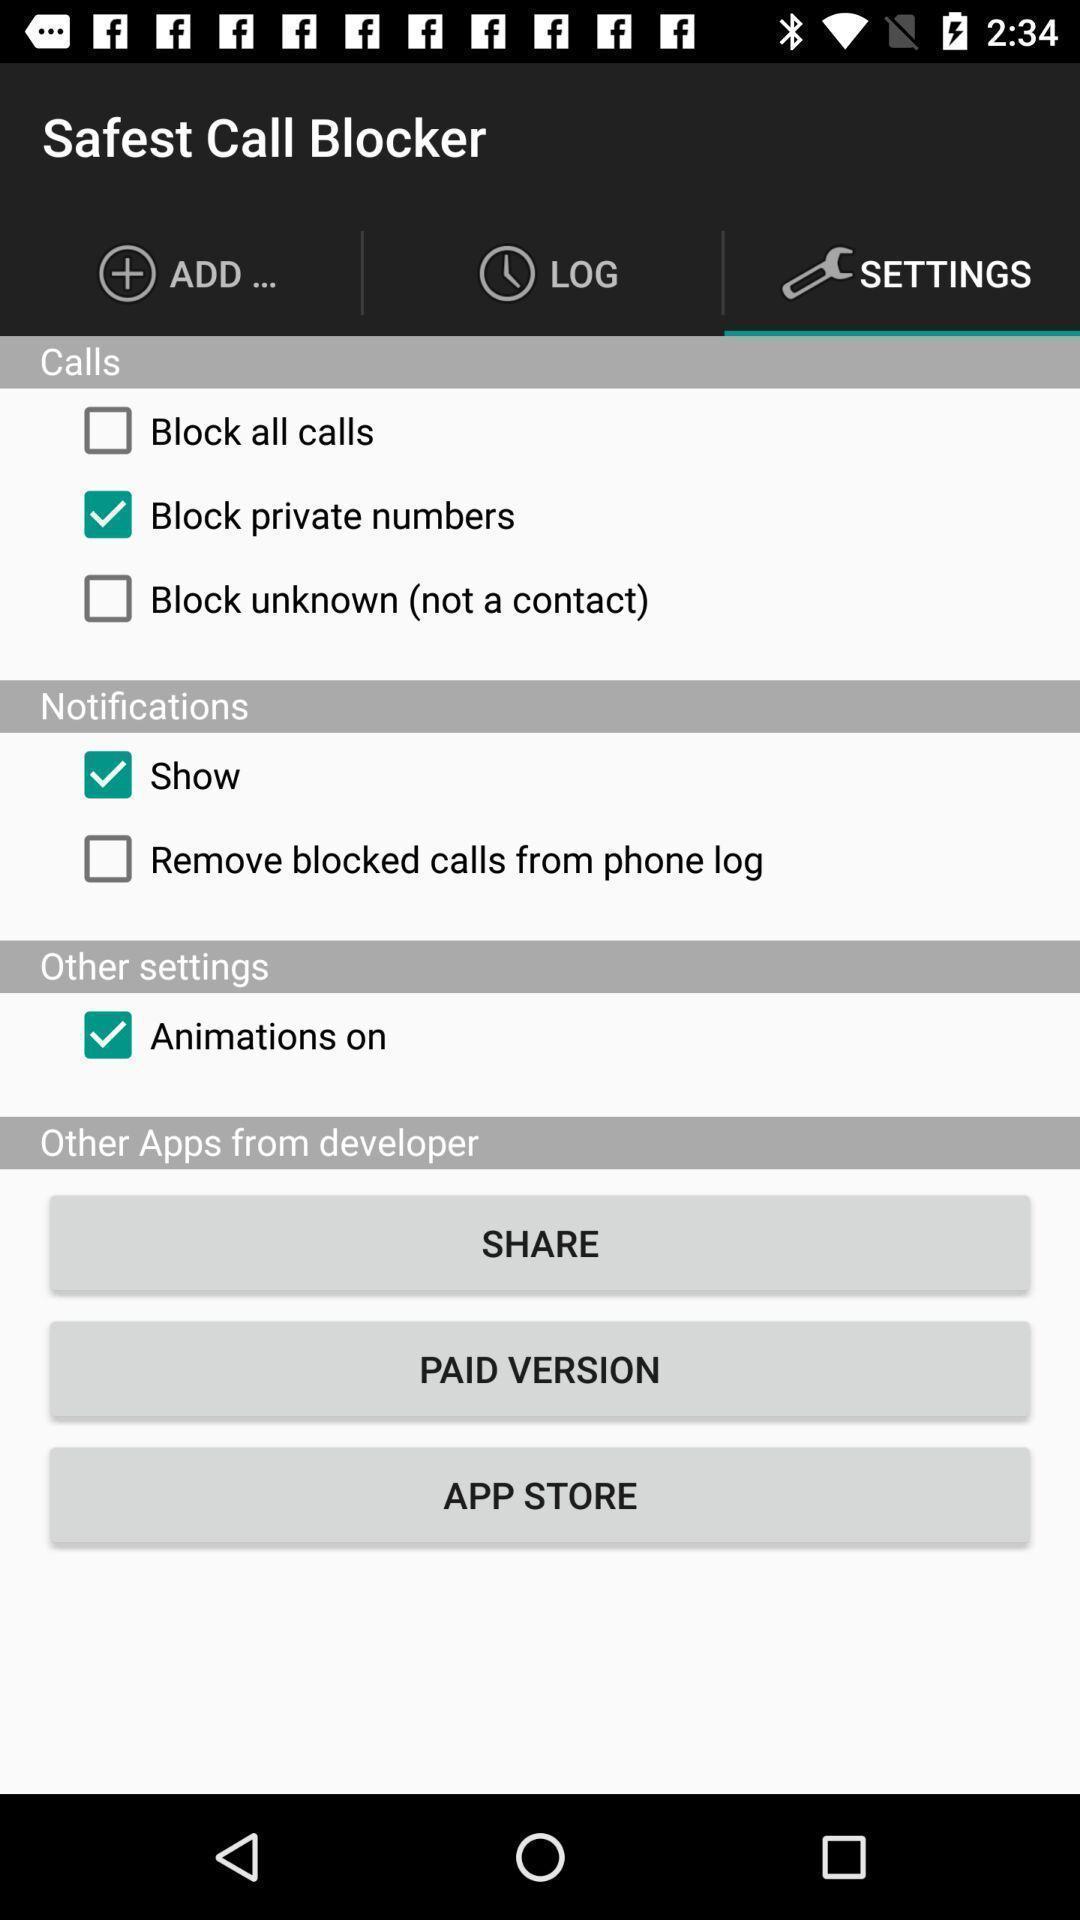Summarize the information in this screenshot. Screen showing settings page of a call blocker app. 